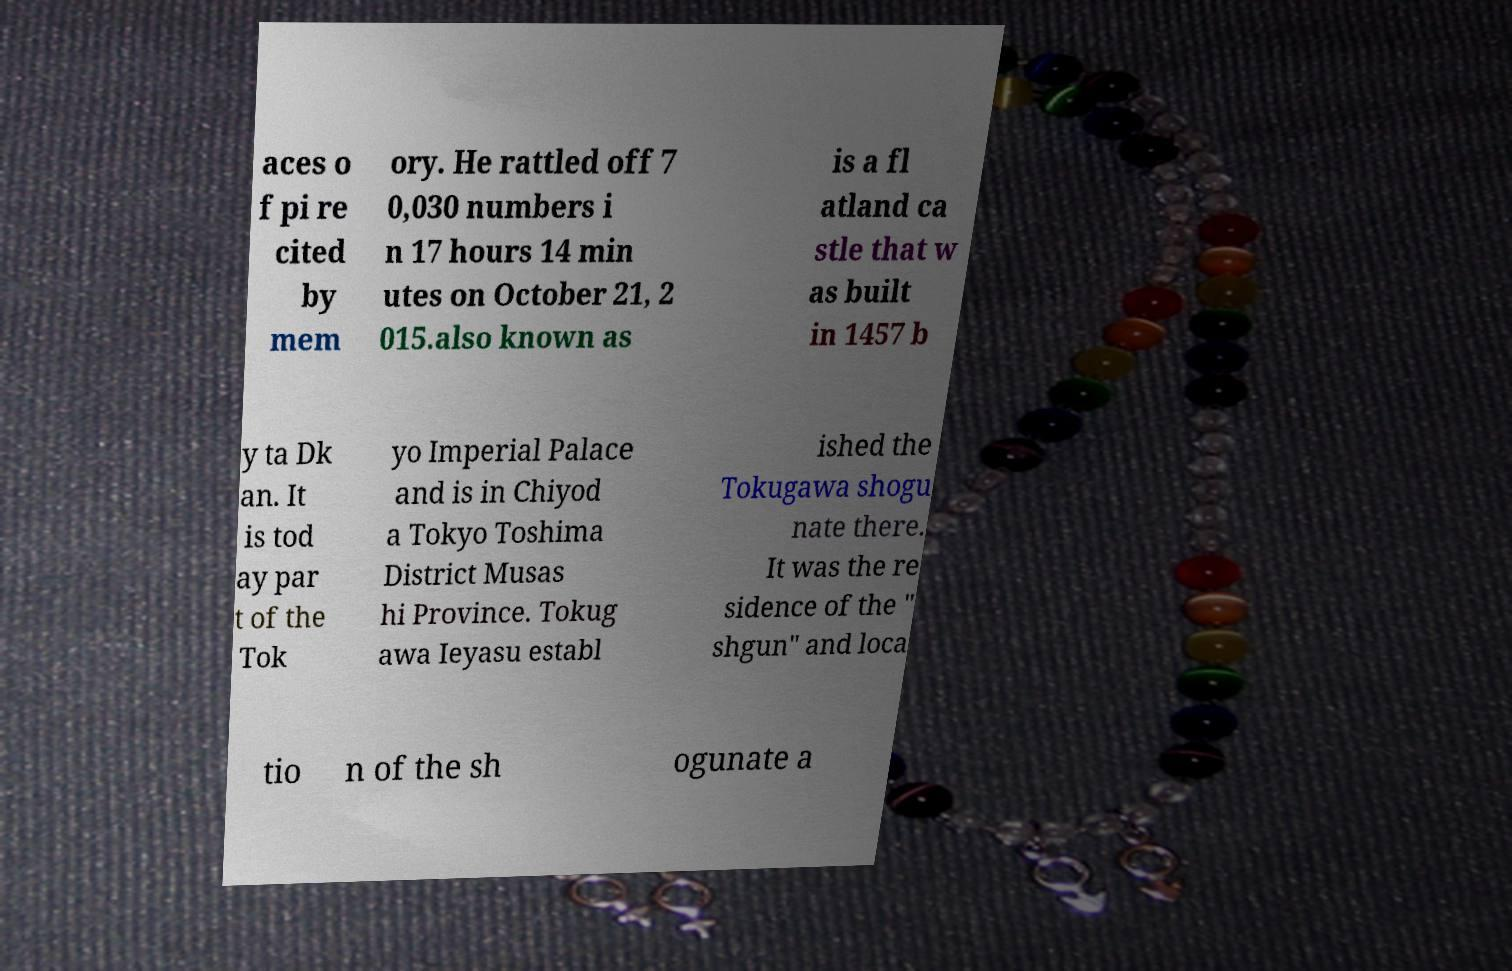Please read and relay the text visible in this image. What does it say? aces o f pi re cited by mem ory. He rattled off 7 0,030 numbers i n 17 hours 14 min utes on October 21, 2 015.also known as is a fl atland ca stle that w as built in 1457 b y ta Dk an. It is tod ay par t of the Tok yo Imperial Palace and is in Chiyod a Tokyo Toshima District Musas hi Province. Tokug awa Ieyasu establ ished the Tokugawa shogu nate there. It was the re sidence of the " shgun" and loca tio n of the sh ogunate a 